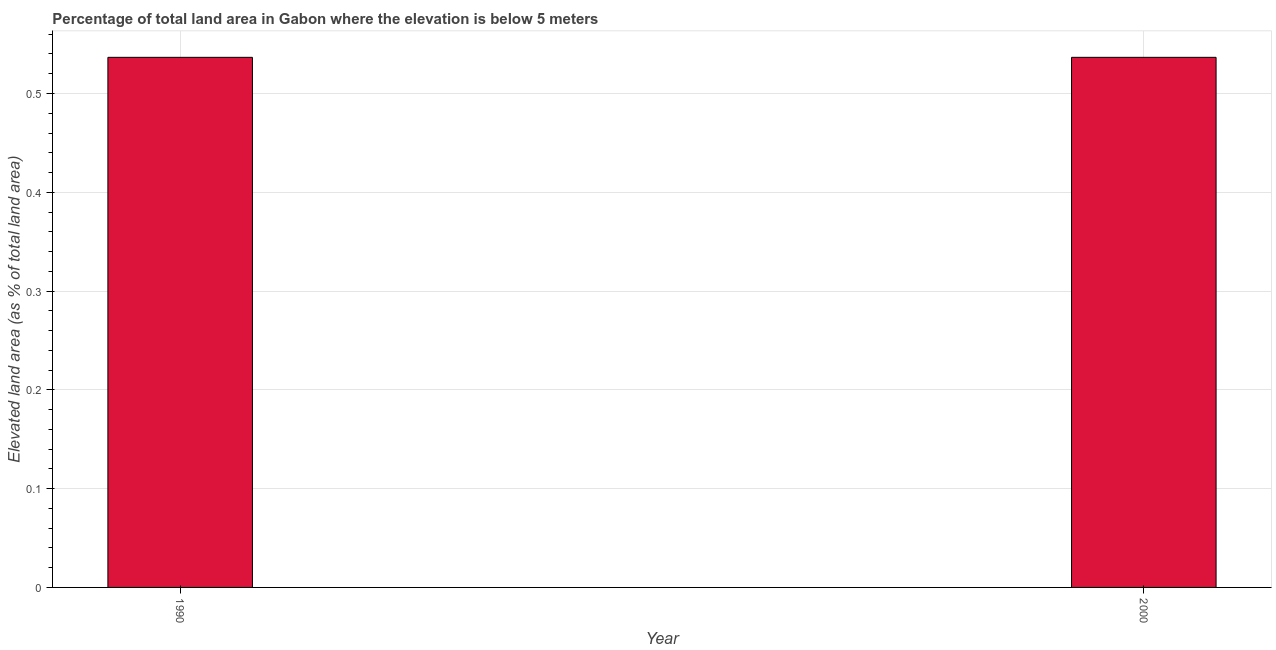Does the graph contain any zero values?
Ensure brevity in your answer.  No. Does the graph contain grids?
Offer a very short reply. Yes. What is the title of the graph?
Ensure brevity in your answer.  Percentage of total land area in Gabon where the elevation is below 5 meters. What is the label or title of the Y-axis?
Provide a short and direct response. Elevated land area (as % of total land area). What is the total elevated land area in 2000?
Your answer should be compact. 0.54. Across all years, what is the maximum total elevated land area?
Offer a terse response. 0.54. Across all years, what is the minimum total elevated land area?
Give a very brief answer. 0.54. In which year was the total elevated land area maximum?
Give a very brief answer. 1990. What is the sum of the total elevated land area?
Ensure brevity in your answer.  1.07. What is the average total elevated land area per year?
Give a very brief answer. 0.54. What is the median total elevated land area?
Ensure brevity in your answer.  0.54. Is the total elevated land area in 1990 less than that in 2000?
Provide a short and direct response. No. In how many years, is the total elevated land area greater than the average total elevated land area taken over all years?
Offer a terse response. 0. How many years are there in the graph?
Offer a very short reply. 2. What is the difference between two consecutive major ticks on the Y-axis?
Offer a very short reply. 0.1. Are the values on the major ticks of Y-axis written in scientific E-notation?
Your response must be concise. No. What is the Elevated land area (as % of total land area) of 1990?
Ensure brevity in your answer.  0.54. What is the Elevated land area (as % of total land area) in 2000?
Your answer should be compact. 0.54. What is the difference between the Elevated land area (as % of total land area) in 1990 and 2000?
Your response must be concise. 0. 